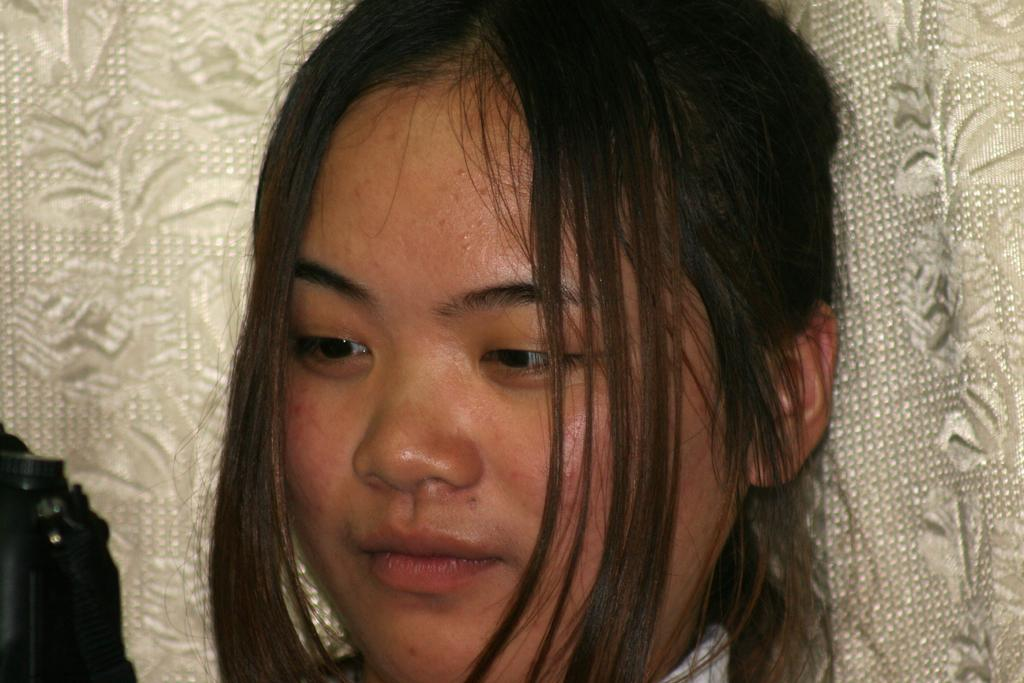What is the main subject of the image? There is a person's face in the image. What color is the background of the image? The background of the image is white. What type of powder is being used by the person in the image? There is no indication of any powder being used in the image; it only features a person's face and a white background. 